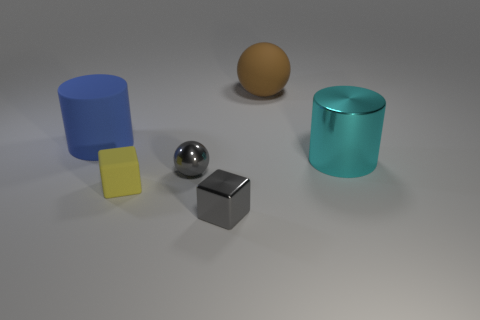Add 4 large cyan objects. How many objects exist? 10 Subtract all cubes. How many objects are left? 4 Add 5 rubber cylinders. How many rubber cylinders exist? 6 Subtract 0 green balls. How many objects are left? 6 Subtract all large cyan cylinders. Subtract all large things. How many objects are left? 2 Add 5 big rubber objects. How many big rubber objects are left? 7 